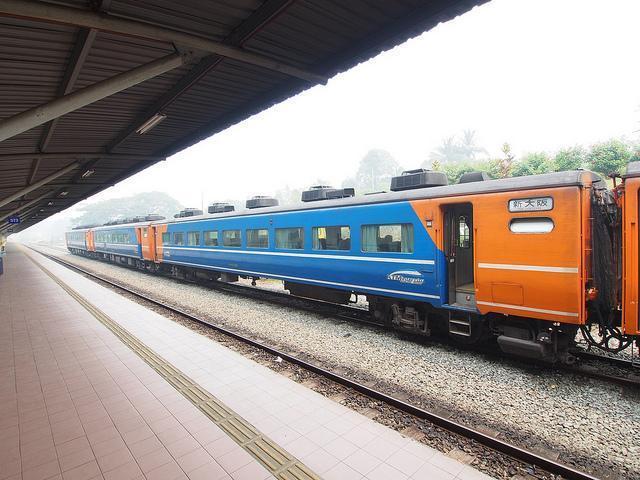How many tracks are there?
Give a very brief answer. 2. How many people are in the image?
Give a very brief answer. 0. 